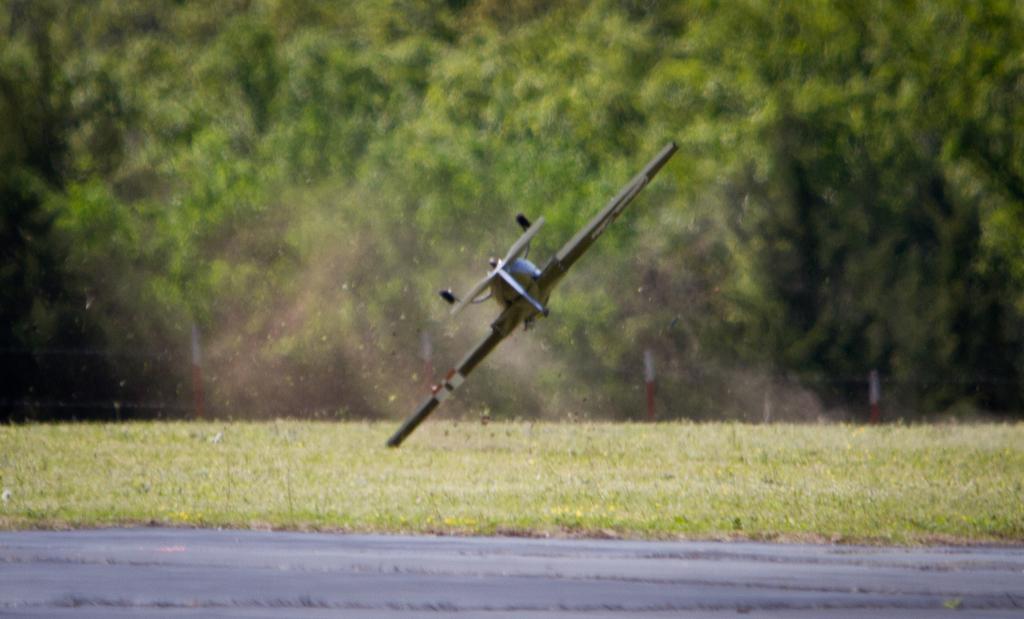In one or two sentences, can you explain what this image depicts? This is an outside view. On the ground I can see the grass. At the bottom there is a road. In the middle of the image there is an aircraft. In the background there are many trees. 